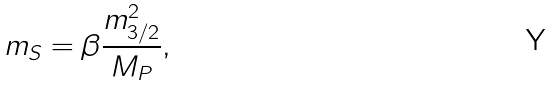Convert formula to latex. <formula><loc_0><loc_0><loc_500><loc_500>m _ { S } = \beta \frac { m _ { 3 / 2 } ^ { 2 } } { M _ { P } } ,</formula> 